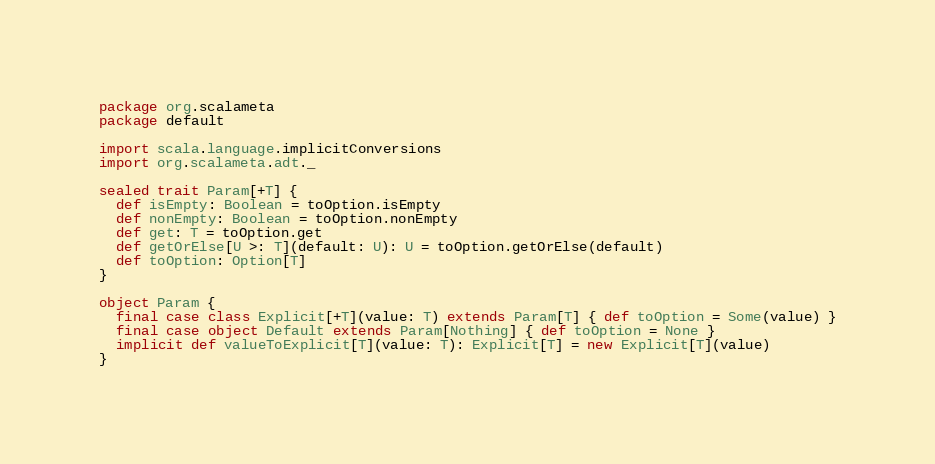Convert code to text. <code><loc_0><loc_0><loc_500><loc_500><_Scala_>package org.scalameta
package default

import scala.language.implicitConversions
import org.scalameta.adt._

sealed trait Param[+T] {
  def isEmpty: Boolean = toOption.isEmpty
  def nonEmpty: Boolean = toOption.nonEmpty
  def get: T = toOption.get
  def getOrElse[U >: T](default: U): U = toOption.getOrElse(default)
  def toOption: Option[T]
}

object Param {
  final case class Explicit[+T](value: T) extends Param[T] { def toOption = Some(value) }
  final case object Default extends Param[Nothing] { def toOption = None }
  implicit def valueToExplicit[T](value: T): Explicit[T] = new Explicit[T](value)
}</code> 